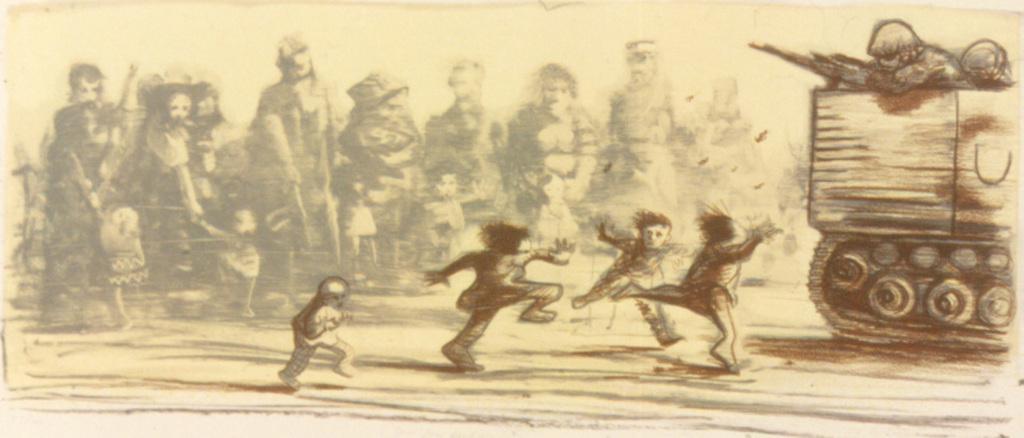Can you describe this image briefly? In this picture there is a drawing paper. In the front we can see a small boys running and playing in the ground. On the right corner we can see a military tank. 